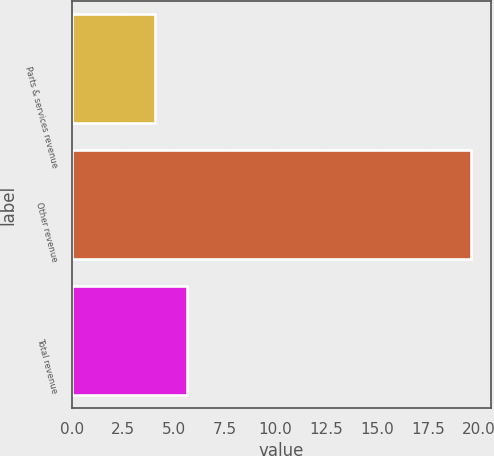Convert chart to OTSL. <chart><loc_0><loc_0><loc_500><loc_500><bar_chart><fcel>Parts & services revenue<fcel>Other revenue<fcel>Total revenue<nl><fcel>4.1<fcel>19.6<fcel>5.65<nl></chart> 